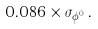<formula> <loc_0><loc_0><loc_500><loc_500>0 . 0 8 6 \times \sigma _ { \phi ^ { 0 } } \, .</formula> 